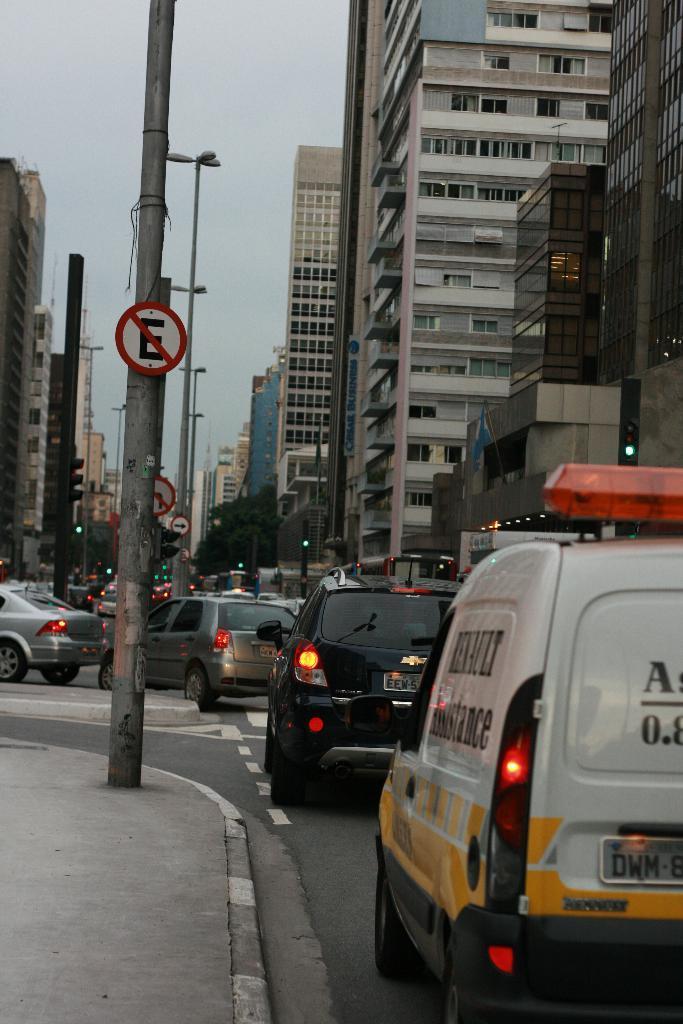How would you summarize this image in a sentence or two? This picture is clicked outside the city. At the bottom, we see the cars are moving on the road. On the left side, we see a footpath and a pole. We even see a board in white and red color. There are trees, buildings and poles in the background. At the top, we see the sky. 